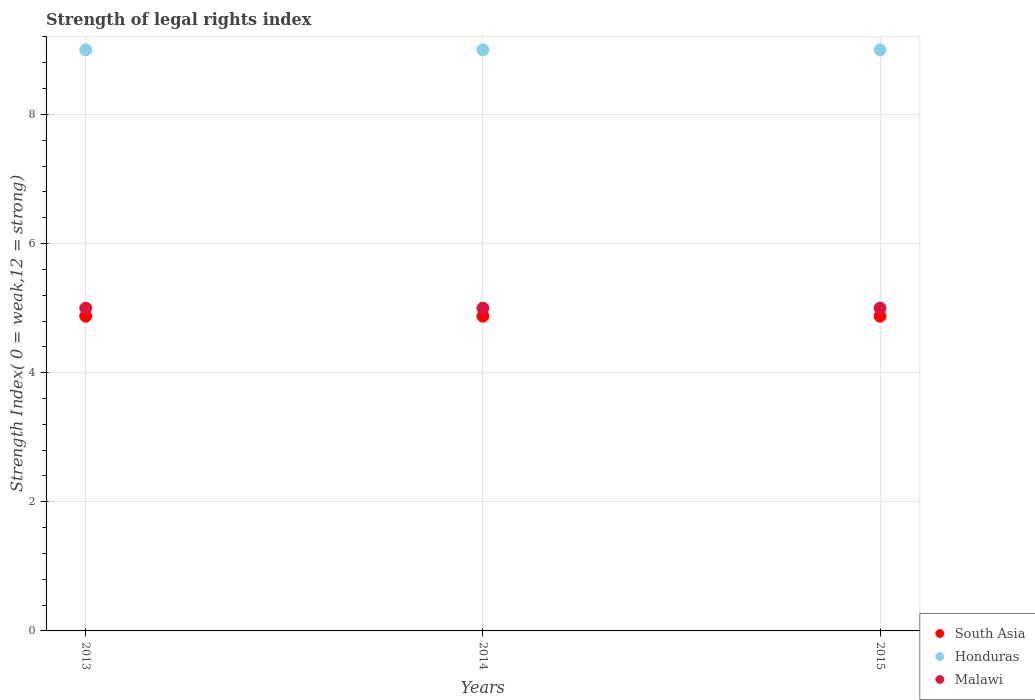How many different coloured dotlines are there?
Your answer should be compact. 3. Is the number of dotlines equal to the number of legend labels?
Give a very brief answer. Yes. What is the strength index in Honduras in 2013?
Your answer should be compact. 9. Across all years, what is the maximum strength index in South Asia?
Provide a succinct answer. 4.88. Across all years, what is the minimum strength index in South Asia?
Offer a very short reply. 4.88. In which year was the strength index in Malawi maximum?
Make the answer very short. 2013. In which year was the strength index in Malawi minimum?
Offer a terse response. 2013. What is the total strength index in Malawi in the graph?
Provide a short and direct response. 15. In the year 2014, what is the difference between the strength index in South Asia and strength index in Honduras?
Your answer should be very brief. -4.12. In how many years, is the strength index in Honduras greater than 8.4?
Provide a succinct answer. 3. What is the ratio of the strength index in South Asia in 2013 to that in 2015?
Keep it short and to the point. 1. Is the strength index in Malawi in 2013 less than that in 2014?
Keep it short and to the point. No. What is the difference between the highest and the second highest strength index in Honduras?
Your response must be concise. 0. What is the difference between the highest and the lowest strength index in Honduras?
Give a very brief answer. 0. In how many years, is the strength index in Malawi greater than the average strength index in Malawi taken over all years?
Ensure brevity in your answer.  0. Is the sum of the strength index in Malawi in 2013 and 2014 greater than the maximum strength index in South Asia across all years?
Keep it short and to the point. Yes. Is it the case that in every year, the sum of the strength index in Malawi and strength index in South Asia  is greater than the strength index in Honduras?
Give a very brief answer. Yes. Does the strength index in Honduras monotonically increase over the years?
Provide a short and direct response. No. Where does the legend appear in the graph?
Your answer should be compact. Bottom right. How many legend labels are there?
Offer a terse response. 3. What is the title of the graph?
Ensure brevity in your answer.  Strength of legal rights index. What is the label or title of the Y-axis?
Provide a short and direct response. Strength Index( 0 = weak,12 = strong). What is the Strength Index( 0 = weak,12 = strong) in South Asia in 2013?
Offer a terse response. 4.88. What is the Strength Index( 0 = weak,12 = strong) of South Asia in 2014?
Make the answer very short. 4.88. What is the Strength Index( 0 = weak,12 = strong) of Honduras in 2014?
Offer a terse response. 9. What is the Strength Index( 0 = weak,12 = strong) in South Asia in 2015?
Give a very brief answer. 4.88. What is the Strength Index( 0 = weak,12 = strong) in Honduras in 2015?
Your answer should be very brief. 9. What is the Strength Index( 0 = weak,12 = strong) of Malawi in 2015?
Give a very brief answer. 5. Across all years, what is the maximum Strength Index( 0 = weak,12 = strong) in South Asia?
Provide a short and direct response. 4.88. Across all years, what is the maximum Strength Index( 0 = weak,12 = strong) in Honduras?
Your answer should be very brief. 9. Across all years, what is the maximum Strength Index( 0 = weak,12 = strong) of Malawi?
Your answer should be compact. 5. Across all years, what is the minimum Strength Index( 0 = weak,12 = strong) in South Asia?
Make the answer very short. 4.88. What is the total Strength Index( 0 = weak,12 = strong) in South Asia in the graph?
Give a very brief answer. 14.62. What is the total Strength Index( 0 = weak,12 = strong) in Honduras in the graph?
Keep it short and to the point. 27. What is the difference between the Strength Index( 0 = weak,12 = strong) of Malawi in 2013 and that in 2014?
Give a very brief answer. 0. What is the difference between the Strength Index( 0 = weak,12 = strong) in South Asia in 2013 and that in 2015?
Offer a terse response. 0. What is the difference between the Strength Index( 0 = weak,12 = strong) of South Asia in 2014 and that in 2015?
Give a very brief answer. 0. What is the difference between the Strength Index( 0 = weak,12 = strong) of Honduras in 2014 and that in 2015?
Ensure brevity in your answer.  0. What is the difference between the Strength Index( 0 = weak,12 = strong) in Malawi in 2014 and that in 2015?
Give a very brief answer. 0. What is the difference between the Strength Index( 0 = weak,12 = strong) in South Asia in 2013 and the Strength Index( 0 = weak,12 = strong) in Honduras in 2014?
Offer a very short reply. -4.12. What is the difference between the Strength Index( 0 = weak,12 = strong) of South Asia in 2013 and the Strength Index( 0 = weak,12 = strong) of Malawi in 2014?
Your answer should be very brief. -0.12. What is the difference between the Strength Index( 0 = weak,12 = strong) of South Asia in 2013 and the Strength Index( 0 = weak,12 = strong) of Honduras in 2015?
Provide a succinct answer. -4.12. What is the difference between the Strength Index( 0 = weak,12 = strong) in South Asia in 2013 and the Strength Index( 0 = weak,12 = strong) in Malawi in 2015?
Your answer should be very brief. -0.12. What is the difference between the Strength Index( 0 = weak,12 = strong) of South Asia in 2014 and the Strength Index( 0 = weak,12 = strong) of Honduras in 2015?
Your answer should be very brief. -4.12. What is the difference between the Strength Index( 0 = weak,12 = strong) of South Asia in 2014 and the Strength Index( 0 = weak,12 = strong) of Malawi in 2015?
Provide a short and direct response. -0.12. What is the average Strength Index( 0 = weak,12 = strong) of South Asia per year?
Provide a short and direct response. 4.88. What is the average Strength Index( 0 = weak,12 = strong) of Honduras per year?
Provide a succinct answer. 9. What is the average Strength Index( 0 = weak,12 = strong) of Malawi per year?
Make the answer very short. 5. In the year 2013, what is the difference between the Strength Index( 0 = weak,12 = strong) in South Asia and Strength Index( 0 = weak,12 = strong) in Honduras?
Make the answer very short. -4.12. In the year 2013, what is the difference between the Strength Index( 0 = weak,12 = strong) of South Asia and Strength Index( 0 = weak,12 = strong) of Malawi?
Your answer should be very brief. -0.12. In the year 2014, what is the difference between the Strength Index( 0 = weak,12 = strong) of South Asia and Strength Index( 0 = weak,12 = strong) of Honduras?
Keep it short and to the point. -4.12. In the year 2014, what is the difference between the Strength Index( 0 = weak,12 = strong) in South Asia and Strength Index( 0 = weak,12 = strong) in Malawi?
Ensure brevity in your answer.  -0.12. In the year 2014, what is the difference between the Strength Index( 0 = weak,12 = strong) in Honduras and Strength Index( 0 = weak,12 = strong) in Malawi?
Offer a terse response. 4. In the year 2015, what is the difference between the Strength Index( 0 = weak,12 = strong) in South Asia and Strength Index( 0 = weak,12 = strong) in Honduras?
Your answer should be compact. -4.12. In the year 2015, what is the difference between the Strength Index( 0 = weak,12 = strong) in South Asia and Strength Index( 0 = weak,12 = strong) in Malawi?
Offer a terse response. -0.12. What is the ratio of the Strength Index( 0 = weak,12 = strong) of South Asia in 2013 to that in 2014?
Keep it short and to the point. 1. What is the ratio of the Strength Index( 0 = weak,12 = strong) of Honduras in 2013 to that in 2015?
Your answer should be very brief. 1. What is the ratio of the Strength Index( 0 = weak,12 = strong) in South Asia in 2014 to that in 2015?
Provide a short and direct response. 1. What is the ratio of the Strength Index( 0 = weak,12 = strong) in Honduras in 2014 to that in 2015?
Your answer should be compact. 1. What is the ratio of the Strength Index( 0 = weak,12 = strong) in Malawi in 2014 to that in 2015?
Give a very brief answer. 1. What is the difference between the highest and the second highest Strength Index( 0 = weak,12 = strong) in Honduras?
Your response must be concise. 0. What is the difference between the highest and the second highest Strength Index( 0 = weak,12 = strong) of Malawi?
Keep it short and to the point. 0. What is the difference between the highest and the lowest Strength Index( 0 = weak,12 = strong) of Malawi?
Provide a succinct answer. 0. 